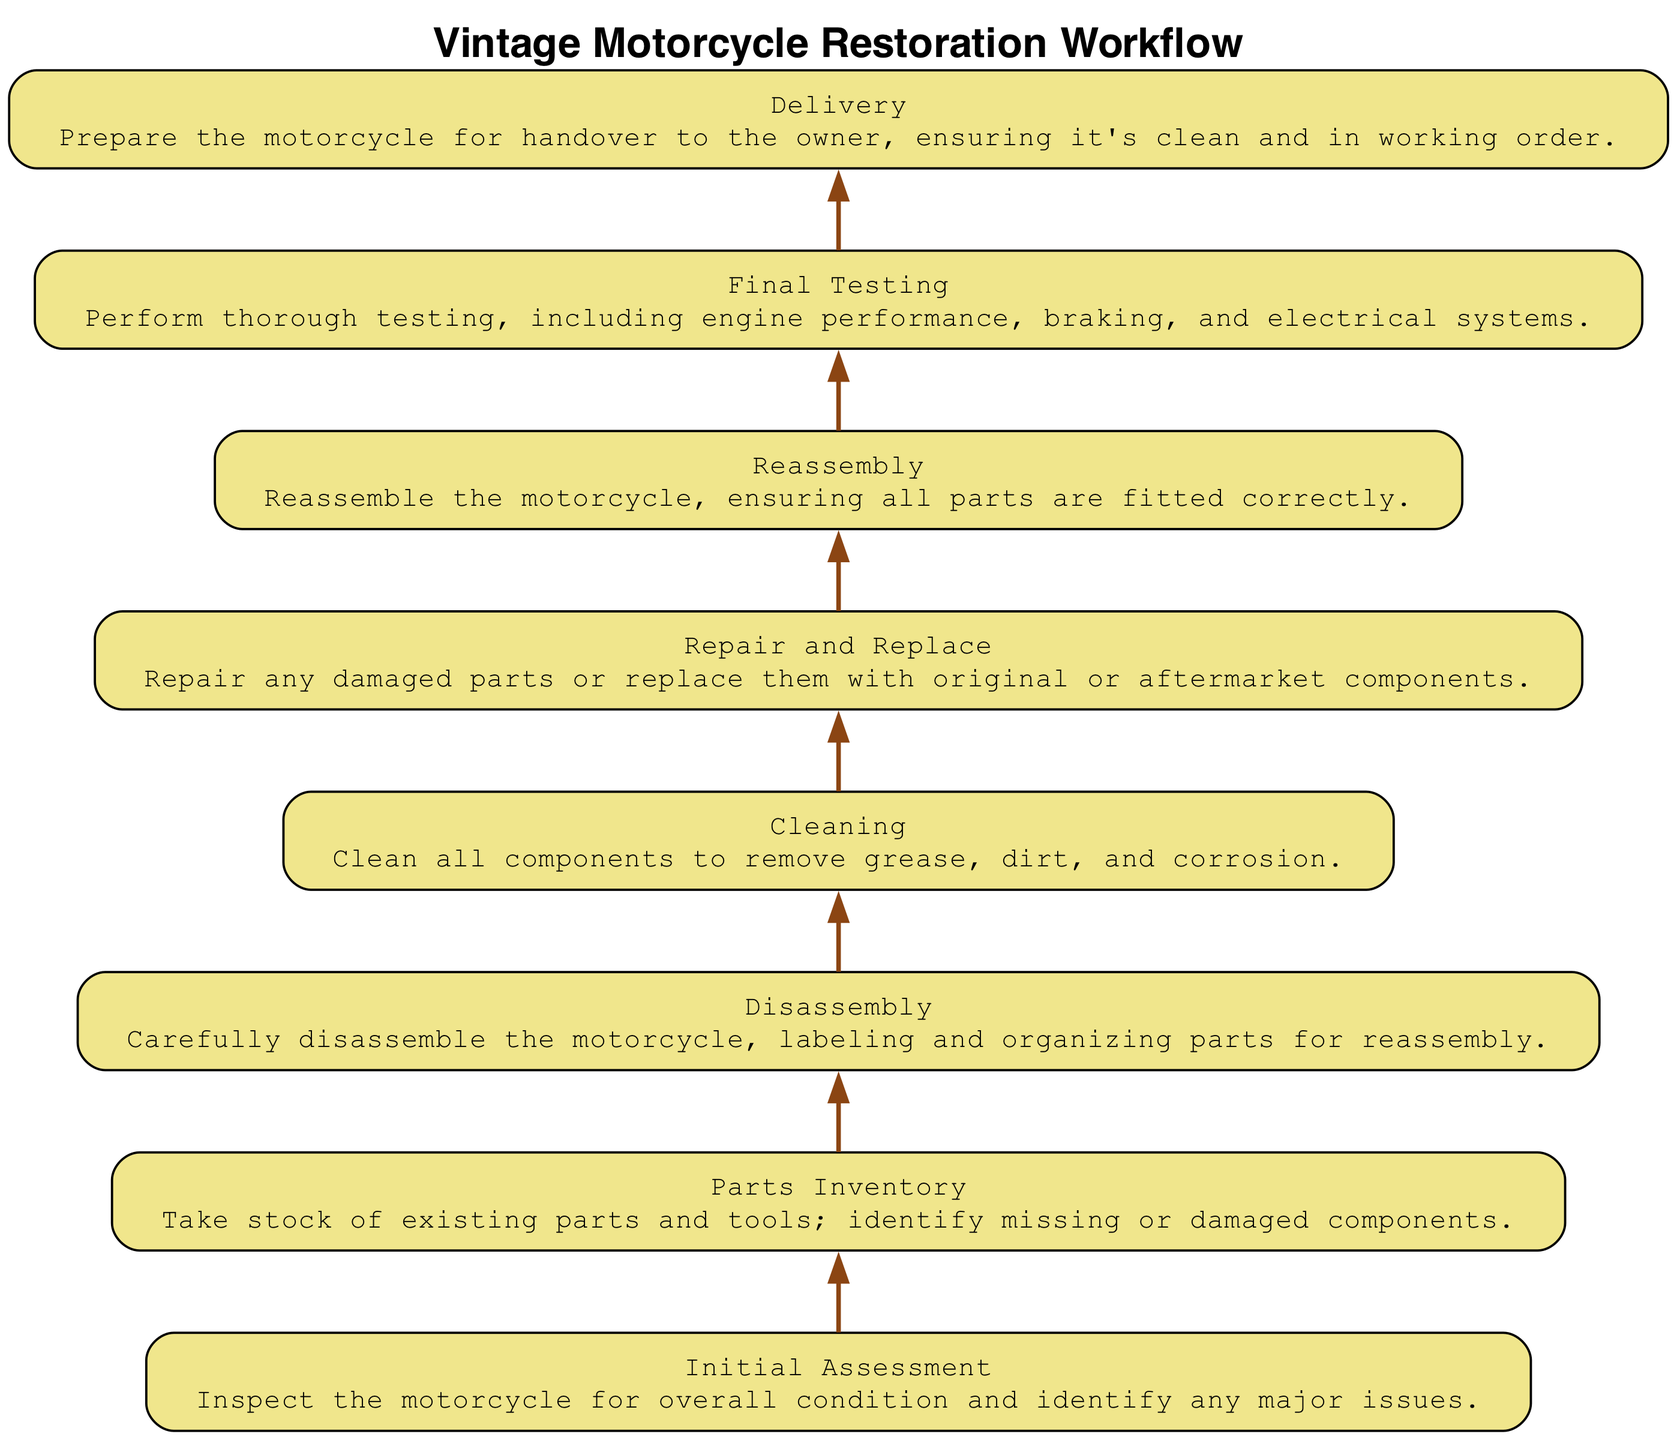What is the first step in the motorcycle restoration workflow? The first step according to the diagram is "Initial Assessment". This is identified by the position of the node at the bottom, which establishes the starting point of the workflow.
Answer: Initial Assessment How many total steps are in the workflow? By counting each node listed in the diagram, there are a total of eight steps involved in the motorcycle restoration process. This includes all nodes from "Initial Assessment" to "Delivery".
Answer: Eight Which step comes directly after "Cleaning"? The diagram shows that the step "Repair and Replace" follows directly after "Cleaning". This sequence is evident by the connecting edge leading from the "Cleaning" node to the "Repair and Replace" node.
Answer: Repair and Replace What is the last step in the workflow? The final step in the workflow, as indicated by the last node in the diagram, is "Delivery". This step is situated at the top after all previous steps have been completed.
Answer: Delivery What does the "Repair and Replace" step involve? The "Repair and Replace" node describes the action of repairing damaged parts or replacing them, based on the information provided within the node itself. This answer is drawn from the details of that specific part of the diagram.
Answer: Repairing or replacing parts How many connections are there between the steps in the workflow? Counting the edges that connect the nodes in the diagram indicates that there are seven connections linking the eight steps together, creating a clear flow between each stage.
Answer: Seven What step is reached before "Final Testing"? According to the workflow diagram, the step leading to "Final Testing" is "Reassembly". There is a direct edge from "Reassembly" to "Final Testing", indicating that it is the immediate predecessor.
Answer: Reassembly Which step focuses on component cleaning? The "Cleaning" step specifically focuses on cleaning components, as explicitly stated in the node description within the diagram. It's represented as a separate unique step in the workflow.
Answer: Cleaning 